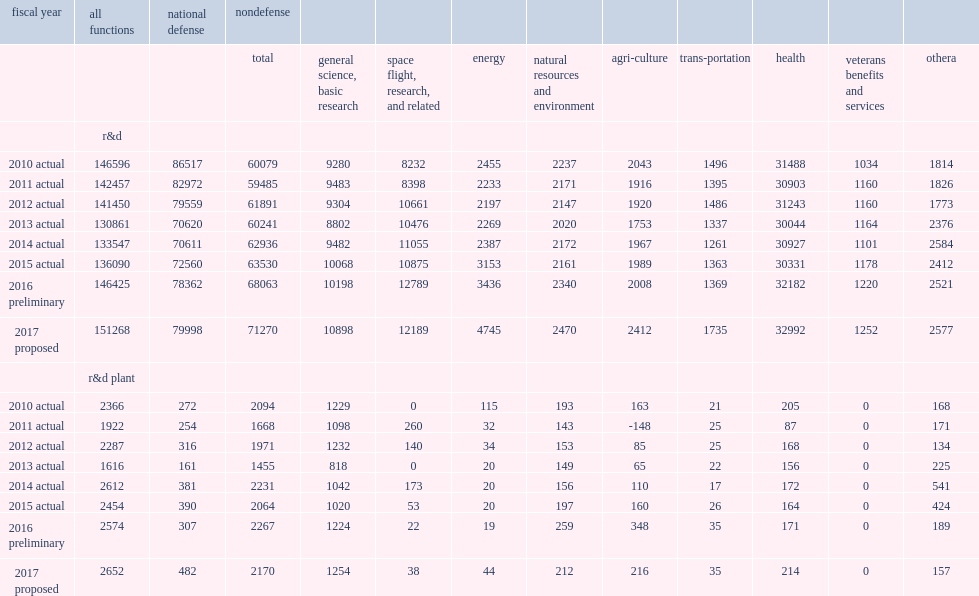How many million dollars of total for federal budget authority in fy 2015? 138544. How many million dollars for r&d in fy 2015? 136090.0. How many million dollars for r&d plant in fy 2015? 2454.0. How many million dollars were the corresponding levels in fy 2016 for r&d? 146425.0. How many million dollars were the corresponding levels in fy 2016 for r&d plant? 2574.0. How many million dollars were the corresponding levels in fy 2017 for r&d? 151268.0. How many million dollars were the corresponding levels in fy 2017 for r&d plant? 2652.0. Give me the full table as a dictionary. {'header': ['fiscal year', 'all functions', 'national defense', 'nondefense', '', '', '', '', '', '', '', '', ''], 'rows': [['', '', '', 'total', 'general science, basic research', 'space flight, research, and related', 'energy', 'natural resources and environment', 'agri-culture', 'trans-portation', 'health', 'veterans benefits and services', 'othera'], ['', 'r&d', '', '', '', '', '', '', '', '', '', '', ''], ['2010 actual', '146596', '86517', '60079', '9280', '8232', '2455', '2237', '2043', '1496', '31488', '1034', '1814'], ['2011 actual', '142457', '82972', '59485', '9483', '8398', '2233', '2171', '1916', '1395', '30903', '1160', '1826'], ['2012 actual', '141450', '79559', '61891', '9304', '10661', '2197', '2147', '1920', '1486', '31243', '1160', '1773'], ['2013 actual', '130861', '70620', '60241', '8802', '10476', '2269', '2020', '1753', '1337', '30044', '1164', '2376'], ['2014 actual', '133547', '70611', '62936', '9482', '11055', '2387', '2172', '1967', '1261', '30927', '1101', '2584'], ['2015 actual', '136090', '72560', '63530', '10068', '10875', '3153', '2161', '1989', '1363', '30331', '1178', '2412'], ['2016 preliminary', '146425', '78362', '68063', '10198', '12789', '3436', '2340', '2008', '1369', '32182', '1220', '2521'], ['2017 proposed', '151268', '79998', '71270', '10898', '12189', '4745', '2470', '2412', '1735', '32992', '1252', '2577'], ['', 'r&d plant', '', '', '', '', '', '', '', '', '', '', ''], ['2010 actual', '2366', '272', '2094', '1229', '0', '115', '193', '163', '21', '205', '0', '168'], ['2011 actual', '1922', '254', '1668', '1098', '260', '32', '143', '-148', '25', '87', '0', '171'], ['2012 actual', '2287', '316', '1971', '1232', '140', '34', '153', '85', '25', '168', '0', '134'], ['2013 actual', '1616', '161', '1455', '818', '0', '20', '149', '65', '22', '156', '0', '225'], ['2014 actual', '2612', '381', '2231', '1042', '173', '20', '156', '110', '17', '172', '0', '541'], ['2015 actual', '2454', '390', '2064', '1020', '53', '20', '197', '160', '26', '164', '0', '424'], ['2016 preliminary', '2574', '307', '2267', '1224', '22', '19', '259', '348', '35', '171', '0', '189'], ['2017 proposed', '2652', '482', '2170', '1254', '38', '44', '212', '216', '35', '214', '0', '157']]} 